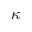<formula> <loc_0><loc_0><loc_500><loc_500>\kappa</formula> 